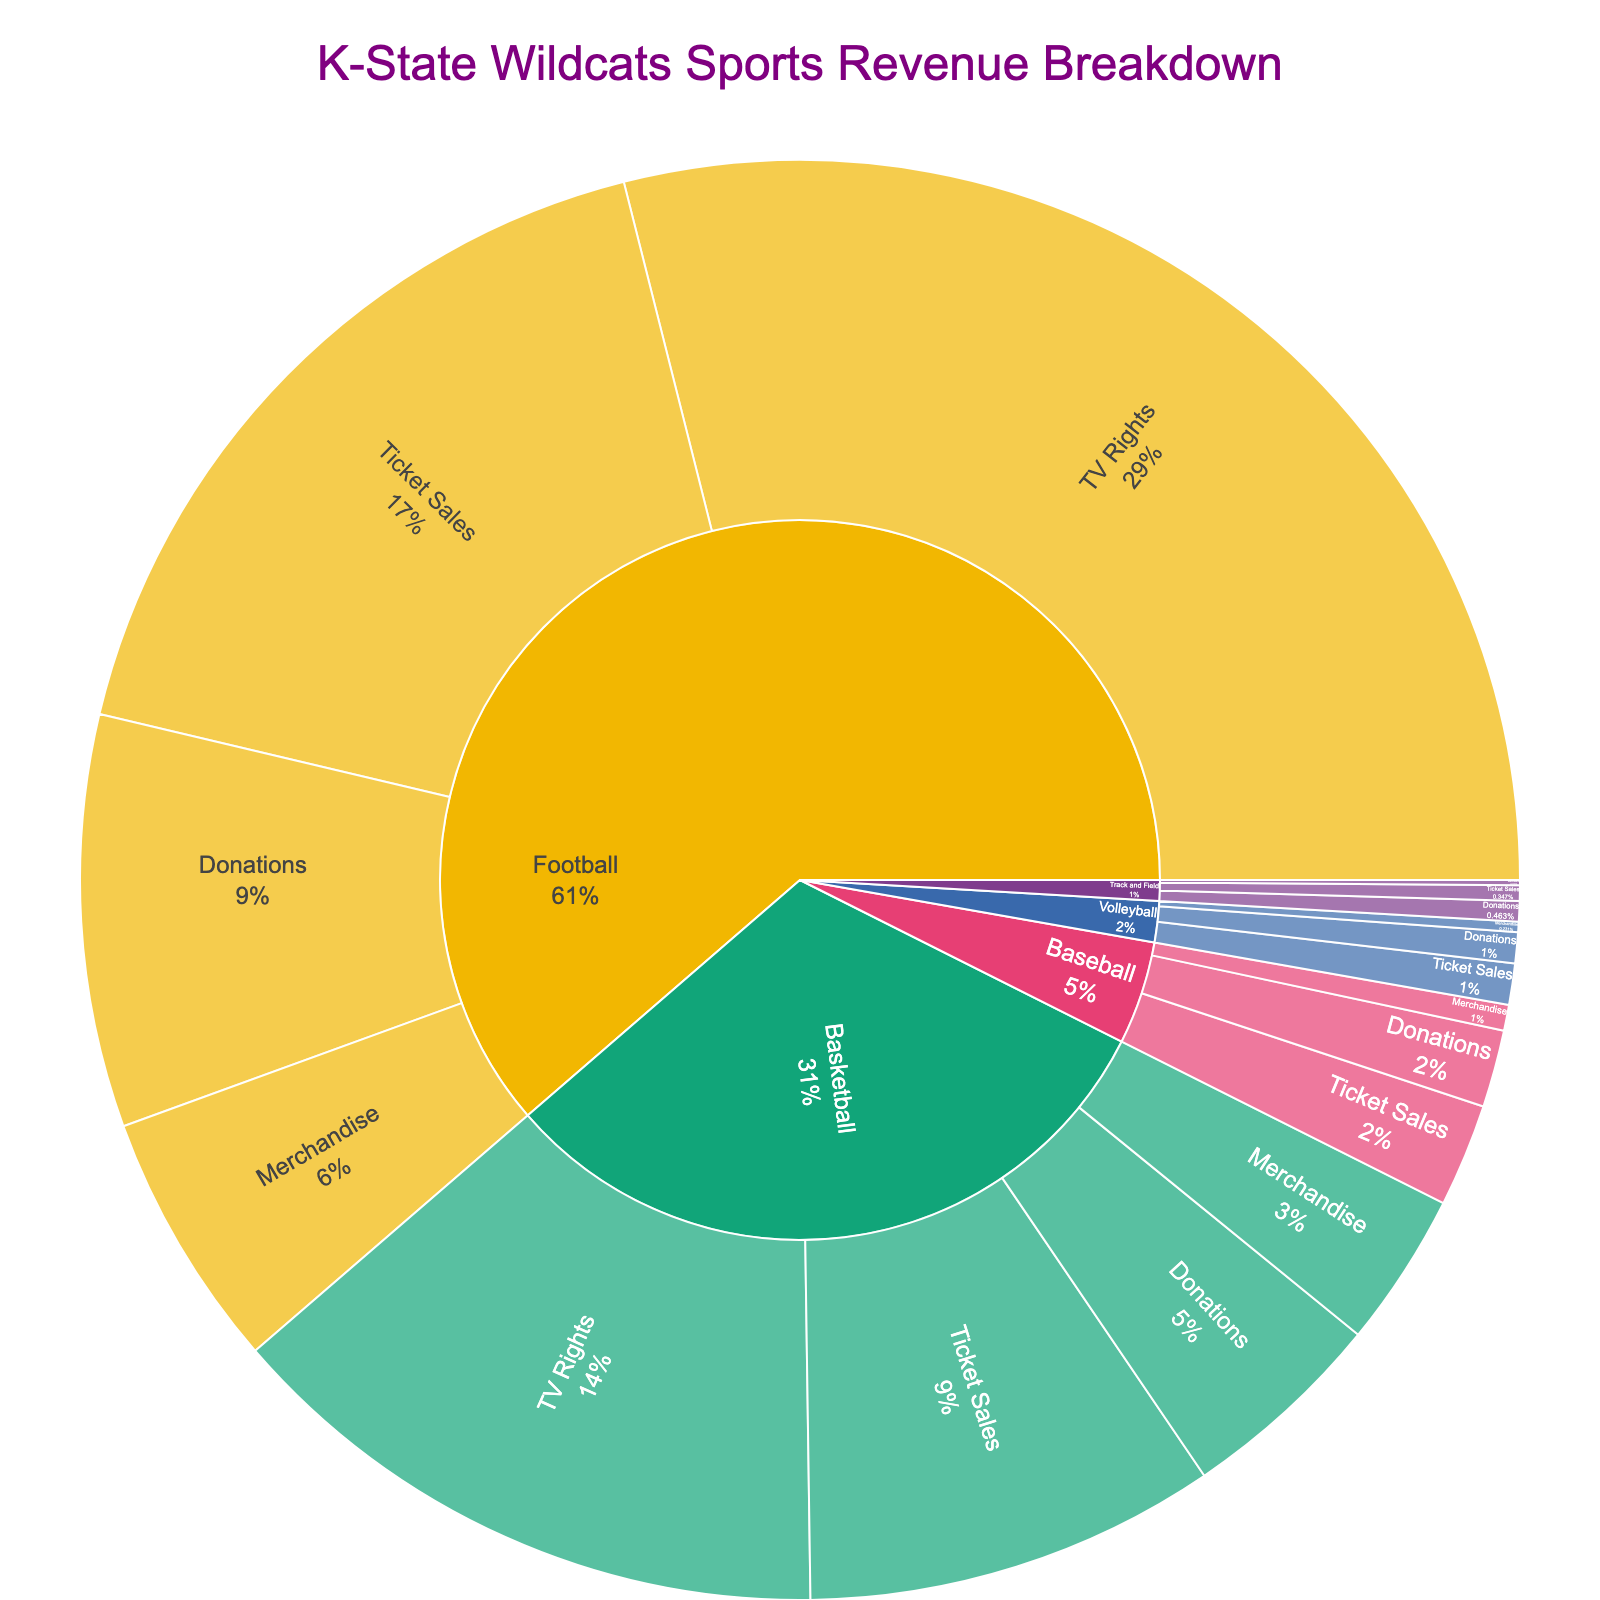What is the title of the plot? The title is usually at the top of the chart and describes the main content or focus. It helps viewers quickly understand what the chart is about.
Answer: "K-State Wildcats Sports Revenue Breakdown" Which team has the highest revenue from TV Rights? By looking at the section labeled "TV Rights" in the Sunburst Plot and identifying which team has the largest area or percentage.
Answer: Football How much revenue does Basketball generate from Merchandise? Locate the Basketball section, then find the part labeled "Merchandise" and check the corresponding amount.
Answer: $3,000,000 Compare the total revenue from Ticket Sales between Football and Basketball. Which generates more? Locate the "Ticket Sales" sections under both Football and Basketball and sum their values. Compare the totals to determine the higher value.
Answer: Football What is the total revenue for Baseball, including all funding sources? Sum the amounts from all funding sources (Ticket Sales, Merchandise, Donations) under Baseball.
Answer: $3,500,000 Which funding source contributes the least overall revenue across all teams? Identify the smallest segments for each funding source in the Sunburst Plot and sum them, comparing totals to find the smallest.
Answer: Track and Field Is the revenue from Donations higher for Football or Basketball? Compare the Donation sections within Football and Basketball to determine which has a larger value.
Answer: Football What percentage of the total Volleyball revenue comes from Ticket Sales? Calculate the percentage by dividing Volleyball's Ticket Sales amount by the total Volleyball revenue from all sources and multiplying by 100.
Answer: 40% Summarize the total amount of revenue from all Ticket Sales across all teams. Sum the values of Ticket Sales from every team.
Answer: $26,100,000 Which team has the smallest portion of revenue from Merchandise? Identify each team's Merchandise section and compare their values to find the smallest.
Answer: Track and Field 